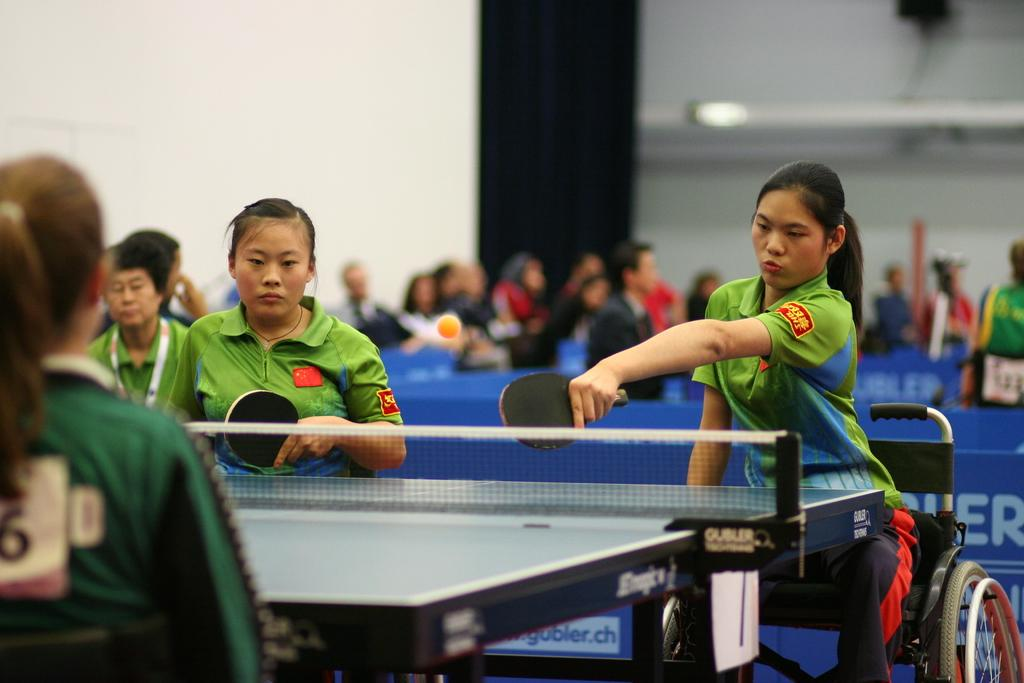How many people are in the image? There are three persons in the image. What are the three persons doing? The three persons are sitting and playing table tennis. How many of the three persons are holding bats? Two persons are holding bats. What can be seen in the background of the image? There is a wall in the background of the image, and there are other persons visible as well. What type of education can be seen in the image? There is no reference to education in the image; it features three persons playing table tennis. What color is the chain that the person is wearing in the image? There is no chain visible on any of the persons in the image. 